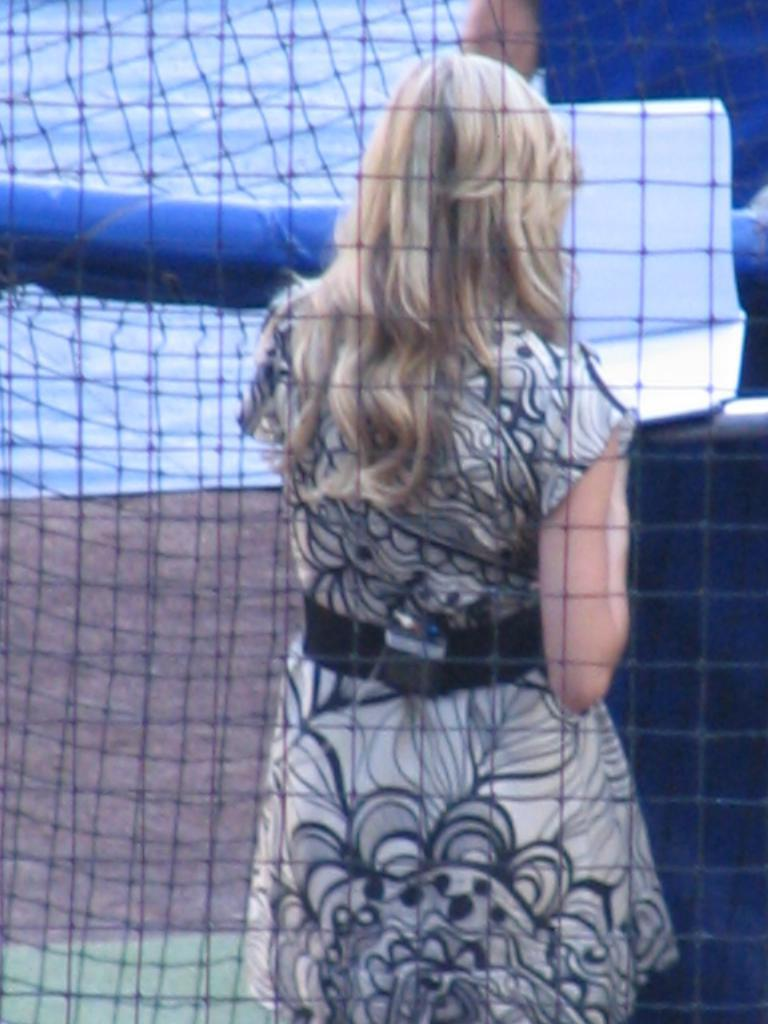What is the main subject in the image? There is a woman standing in the image. What can be seen in the front of the image? There is a net in the front of the image. What is the caption of the image? There is no caption present in the image. How many cents can be seen in the image? There is no mention of currency or cents in the image. 